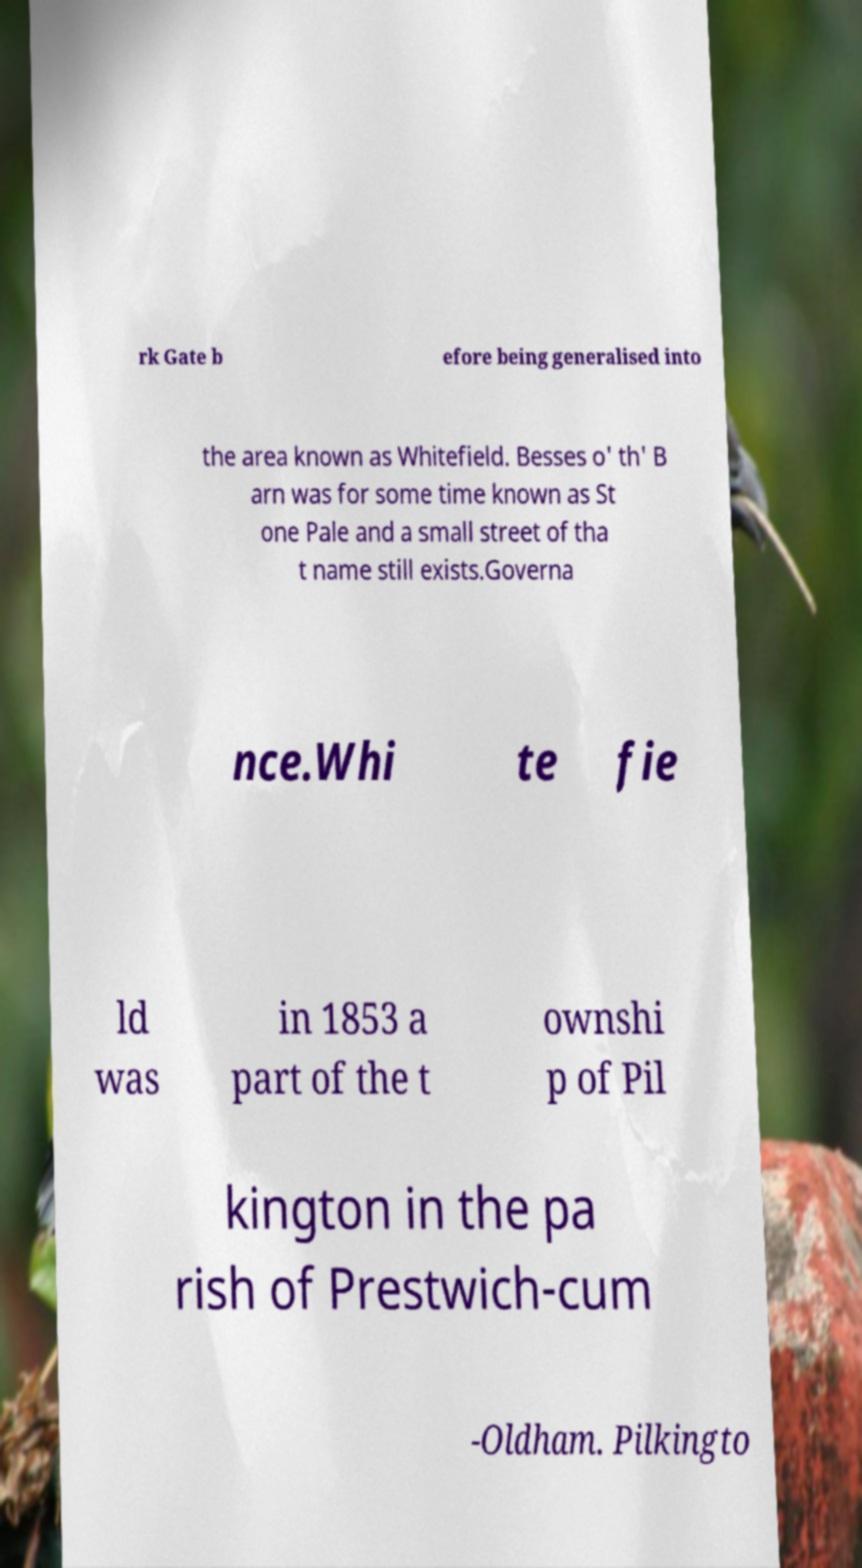Can you accurately transcribe the text from the provided image for me? rk Gate b efore being generalised into the area known as Whitefield. Besses o' th' B arn was for some time known as St one Pale and a small street of tha t name still exists.Governa nce.Whi te fie ld was in 1853 a part of the t ownshi p of Pil kington in the pa rish of Prestwich-cum -Oldham. Pilkingto 